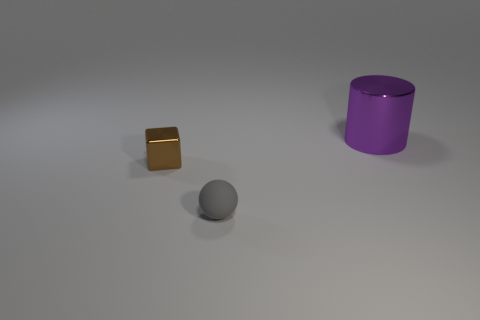Are there any other things that have the same material as the small ball?
Give a very brief answer. No. How many other objects are there of the same shape as the gray rubber thing?
Provide a short and direct response. 0. What number of tiny things are either brown metallic blocks or brown spheres?
Provide a short and direct response. 1. Are there any other things that have the same size as the metallic cylinder?
Your response must be concise. No. What is the material of the object that is behind the metallic object that is to the left of the big purple shiny cylinder?
Provide a succinct answer. Metal. How many metal things are big purple objects or brown things?
Give a very brief answer. 2. How many cylinders are the same color as the tiny rubber ball?
Offer a very short reply. 0. Is there a purple thing that is to the left of the thing in front of the brown shiny thing?
Your answer should be very brief. No. What number of objects are to the left of the tiny rubber thing and behind the small brown metal block?
Your answer should be compact. 0. What number of large purple objects are the same material as the brown block?
Ensure brevity in your answer.  1. 